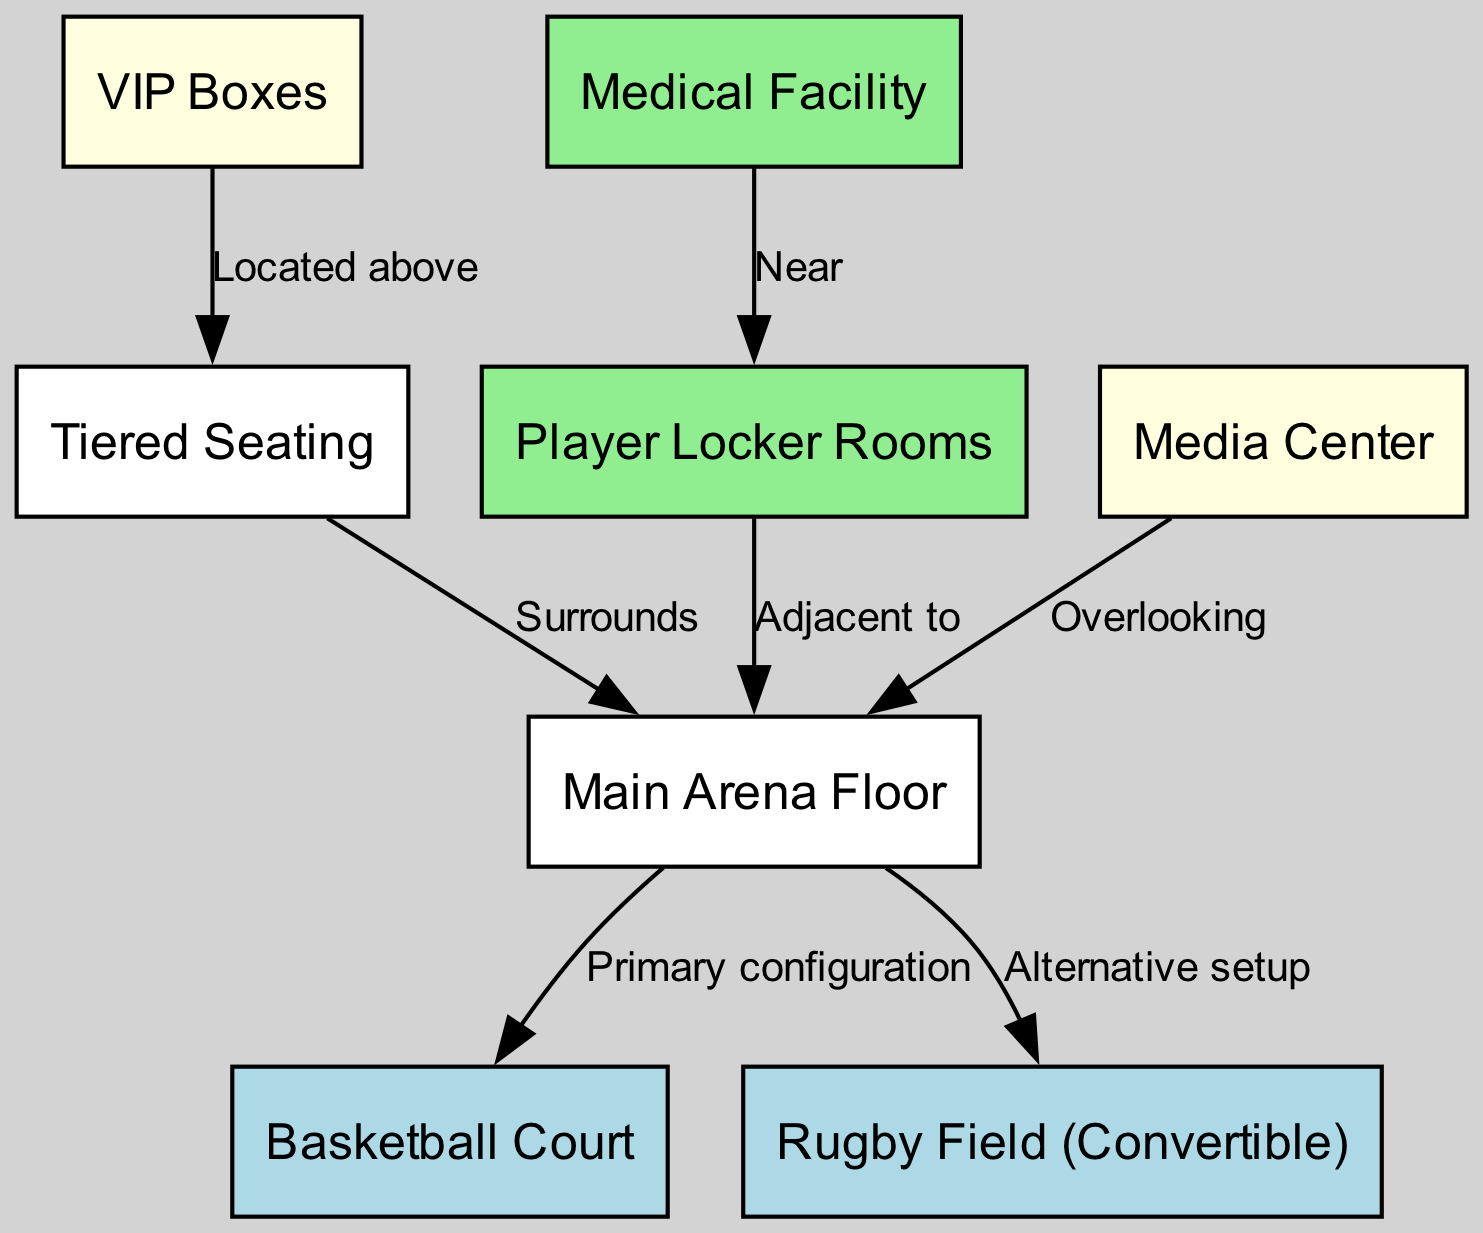What is the primary sports facility featured in the diagram? The main arena is labeled as the primary sports facility in the diagram, indicated as "Main Arena Floor."
Answer: Main Arena Floor How many nodes are present in the diagram? The diagram includes a total of 8 nodes as listed: Main Arena Floor, Basketball Court, Rugby Field, Tiered Seating, VIP Boxes, Player Locker Rooms, Medical Facility, and Media Center.
Answer: 8 Which facility is located adjacent to the locker rooms? The diagram indicates that the Player Locker Rooms are adjacent to the Main Arena. The relationship is explicitly stated in the edge connection.
Answer: Main Arena What color represents the VIP Boxes in the diagram? The VIP Boxes are represented in light yellow, as per the node color coding specified in the diagram setup.
Answer: Light yellow How many edges connect the medical facility to other nodes? The Medical Facility has only one edge connecting it to the locker rooms, which indicates the spatial relationship in the diagram.
Answer: 1 What is the alternative setup indicated for the main arena? The diagram shows the connection from the Main Arena to the Rugby Field, marked as the "Alternative setup," indicating its convertible nature.
Answer: Rugby Field Which areas overlook the main arena? The Media Center is noted to have an edge relationship labeled "Overlooking" with the Main Arena, indicating its visual alignment.
Answer: Media Center What is the purpose of the VIP Boxes according to the diagram? The VIP Boxes are noted to be located above the Tiered Seating, which suggests their function as premium viewing areas.
Answer: Located above How is the seating arranged in relation to the main arena? The seating arrangement is described as "Surrounds" the Main Arena, indicating how seats are positioned around the playing area.
Answer: Surrounds 